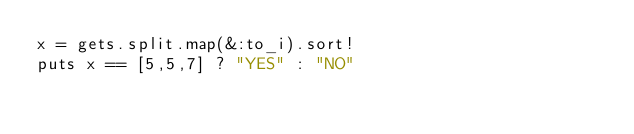<code> <loc_0><loc_0><loc_500><loc_500><_Ruby_>x = gets.split.map(&:to_i).sort!
puts x == [5,5,7] ? "YES" : "NO"</code> 